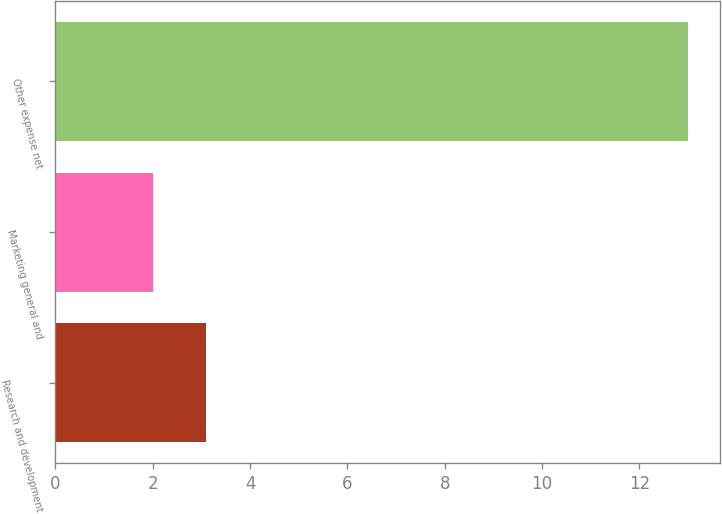Convert chart to OTSL. <chart><loc_0><loc_0><loc_500><loc_500><bar_chart><fcel>Research and development<fcel>Marketing general and<fcel>Other expense net<nl><fcel>3.1<fcel>2<fcel>13<nl></chart> 